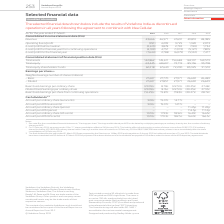From Vodafone Group Plc's financial document, Which financial years' information is shown in the table? The document contains multiple relevant values: 2015, 2016, 2017, 2018, 2019. From the document: "At/for the year ended 31 March 2019 2018 2017 2016 2015 Consolidated income statement data (€m) Revenue 43,666 46,571 47,631 49,810 48,385 O At/for th..." Also, What financial items does the consolidated income statement data comprise of? The document contains multiple relevant values: Revenue, Operating (loss)/profit, (Loss)/profit before taxation, (Loss)/profit for financial year from continuing operations, (Loss)/profit for the financial year. From the document: "ing operations (4,109) 4,757 (1,972) (5,127) 7,805 (Loss)/profit for the financial year (7,644) 2,788 (6,079) (5,122) 7,477 rating (loss)/profit (951)..." Also, What financial items does the consolidated statement of financial position comprise of? The document contains multiple relevant values: Total assets, Total equity, Total equity shareholders’ funds. From the document: "9 Total equity 63,445 68,607 73,719 85,136 93,708 Total equity shareholders’ funds 62,218 67,640 72,200 83,325 91,510 9 Total equity 63,445 68,607 73,..." Also, can you calculate: What is the average revenue for 2018 and 2019? To answer this question, I need to perform calculations using the financial data. The calculation is: (43,666+46,571)/2, which equals 45118.5 (in millions). This is based on the information: "lidated income statement data (€m) Revenue 43,666 46,571 47,631 49,810 48,385 Operating (loss)/profit (951) 4,299 3,725 1,320 2,073 (Loss)/profit before tax 5 Consolidated income statement data (€m) R..." The key data points involved are: 43,666, 46,571. Also, can you calculate: What is the average revenue for 2017 and 2018? To answer this question, I need to perform calculations using the financial data. The calculation is: (46,571+47,631)/2, which equals 47101 (in millions). This is based on the information: "lidated income statement data (€m) Revenue 43,666 46,571 47,631 49,810 48,385 Operating (loss)/profit (951) 4,299 3,725 1,320 2,073 (Loss)/profit before tax income statement data (€m) Revenue 43,666 4..." The key data points involved are: 46,571, 47,631. Additionally, Between 2018 and 2019, which year has a higher amount of revenue? According to the financial document, 2018. The relevant text states: "At/for the year ended 31 March 2019 2018 2017 2016 2015 Consolidated income statement data (€m) Revenue 43,666 46,571 47,631 49,810 48,385 O..." 